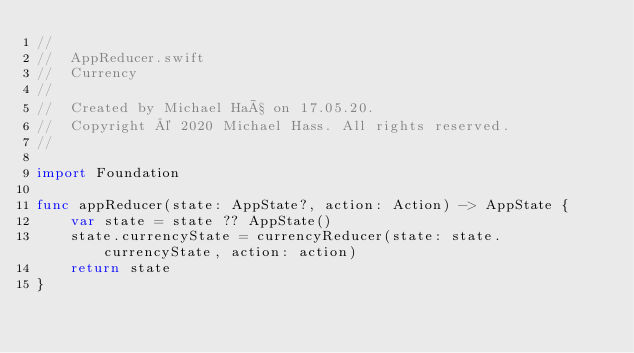<code> <loc_0><loc_0><loc_500><loc_500><_Swift_>//
//  AppReducer.swift
//  Currency
//
//  Created by Michael Haß on 17.05.20.
//  Copyright © 2020 Michael Hass. All rights reserved.
//

import Foundation

func appReducer(state: AppState?, action: Action) -> AppState {
    var state = state ?? AppState()
    state.currencyState = currencyReducer(state: state.currencyState, action: action)
    return state
}
</code> 